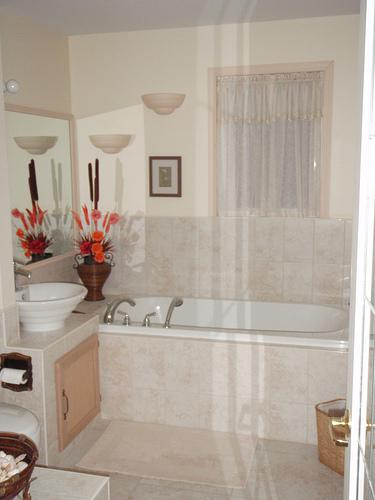Question: what color are the flowers?
Choices:
A. Orange.
B. Yellow.
C. Red.
D. Pink.
Answer with the letter. Answer: A Question: where are the flowers?
Choices:
A. Garden.
B. Vase.
C. Park.
D. Flower shop.
Answer with the letter. Answer: B Question: how many facets are in the tub?
Choices:
A. 1.
B. 2.
C. 3.
D. 4.
Answer with the letter. Answer: B 